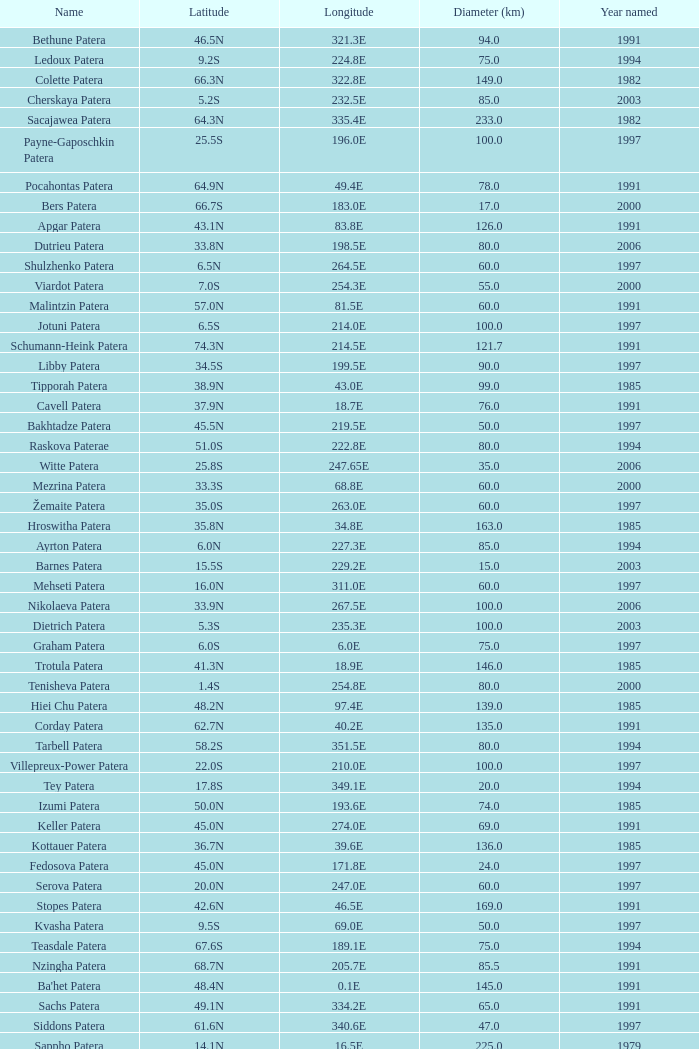What is Longitude, when Name is Raskova Paterae? 222.8E. 